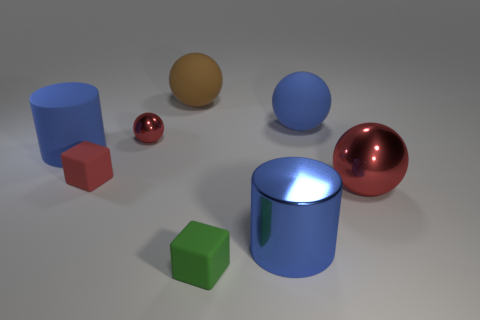Subtract all large spheres. How many spheres are left? 1 Add 2 large red metal cylinders. How many objects exist? 10 Subtract all brown spheres. How many spheres are left? 3 Subtract all cylinders. How many objects are left? 6 Subtract all blue rubber spheres. Subtract all big red shiny spheres. How many objects are left? 6 Add 1 spheres. How many spheres are left? 5 Add 8 big brown spheres. How many big brown spheres exist? 9 Subtract 0 cyan blocks. How many objects are left? 8 Subtract all red cubes. Subtract all blue spheres. How many cubes are left? 1 Subtract all green balls. How many blue blocks are left? 0 